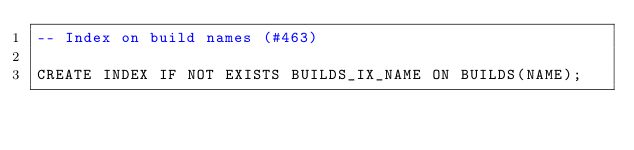Convert code to text. <code><loc_0><loc_0><loc_500><loc_500><_SQL_>-- Index on build names (#463)

CREATE INDEX IF NOT EXISTS BUILDS_IX_NAME ON BUILDS(NAME);
</code> 